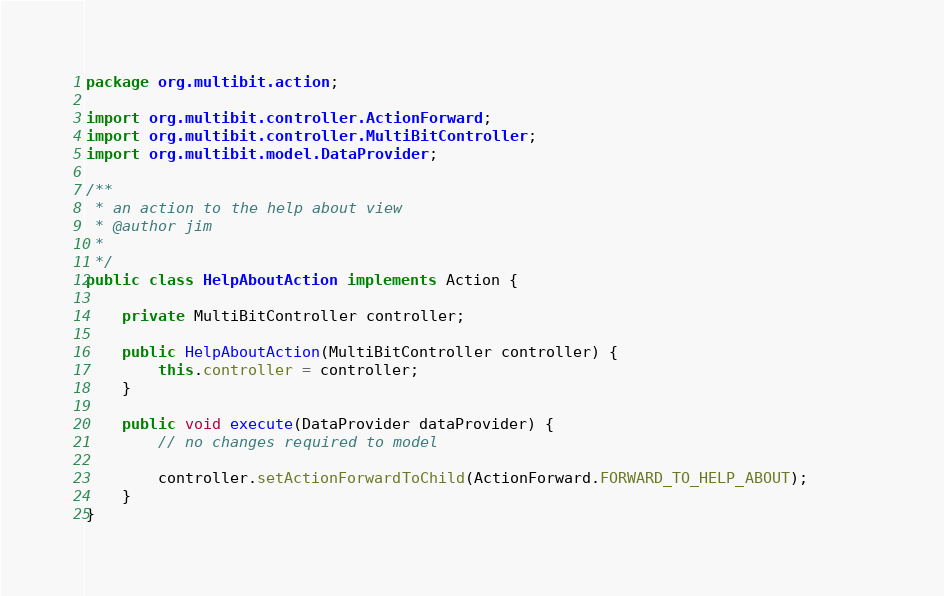<code> <loc_0><loc_0><loc_500><loc_500><_Java_>package org.multibit.action;

import org.multibit.controller.ActionForward;
import org.multibit.controller.MultiBitController;
import org.multibit.model.DataProvider;

/**
 * an action to the help about view
 * @author jim
 *
 */
public class HelpAboutAction implements Action {

    private MultiBitController controller;
    
    public HelpAboutAction(MultiBitController controller) {
        this.controller = controller;     
    }
    
    public void execute(DataProvider dataProvider) {
        // no changes required to model
        
        controller.setActionForwardToChild(ActionForward.FORWARD_TO_HELP_ABOUT);       
    }
}
</code> 